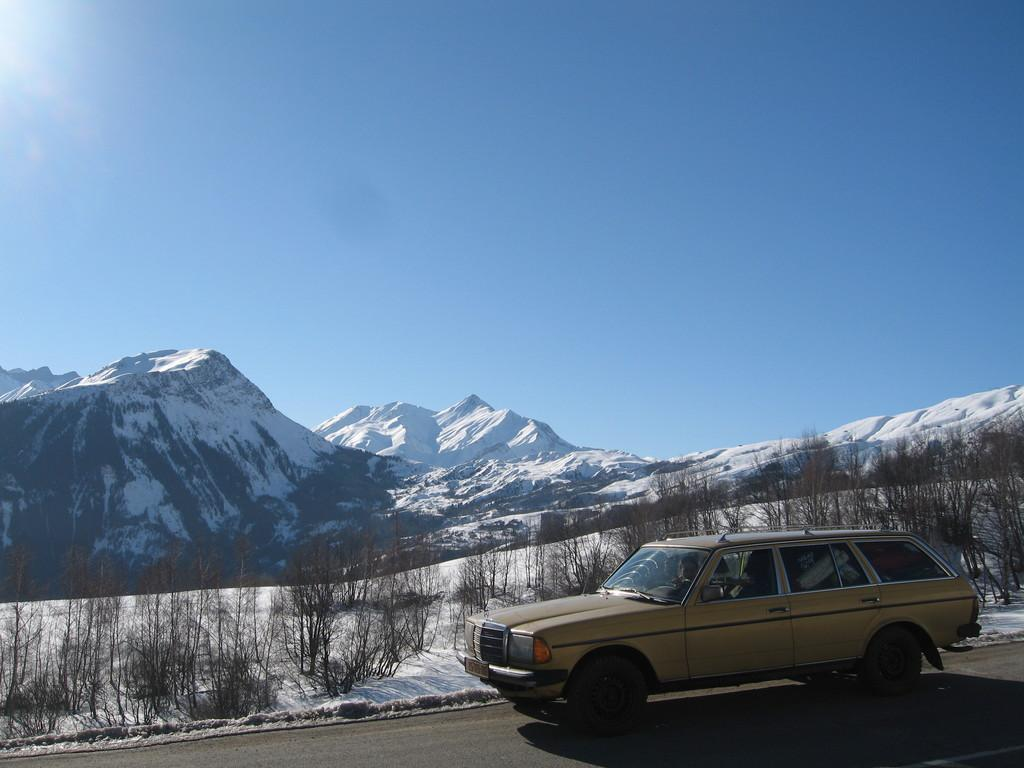What is the main subject of the image? There is a car on the road in the image. What can be seen on the sides of the road? Plants are visible from left to right in the image. What is visible in the background of the image? Mountains covered with snow are visible in the background of the image. What is the color of the sky in the image? The sky is blue in color in the image. What type of pie is being served on the car's roof in the image? There is no pie present in the image, nor is there any indication that food is being served on the car's roof. 